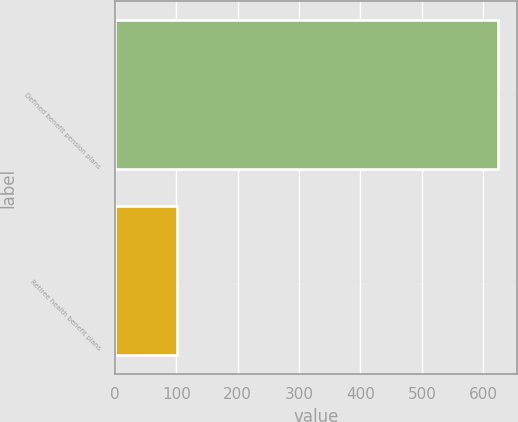<chart> <loc_0><loc_0><loc_500><loc_500><bar_chart><fcel>Defined benefit pension plans<fcel>Retiree health benefit plans<nl><fcel>623.6<fcel>100.7<nl></chart> 